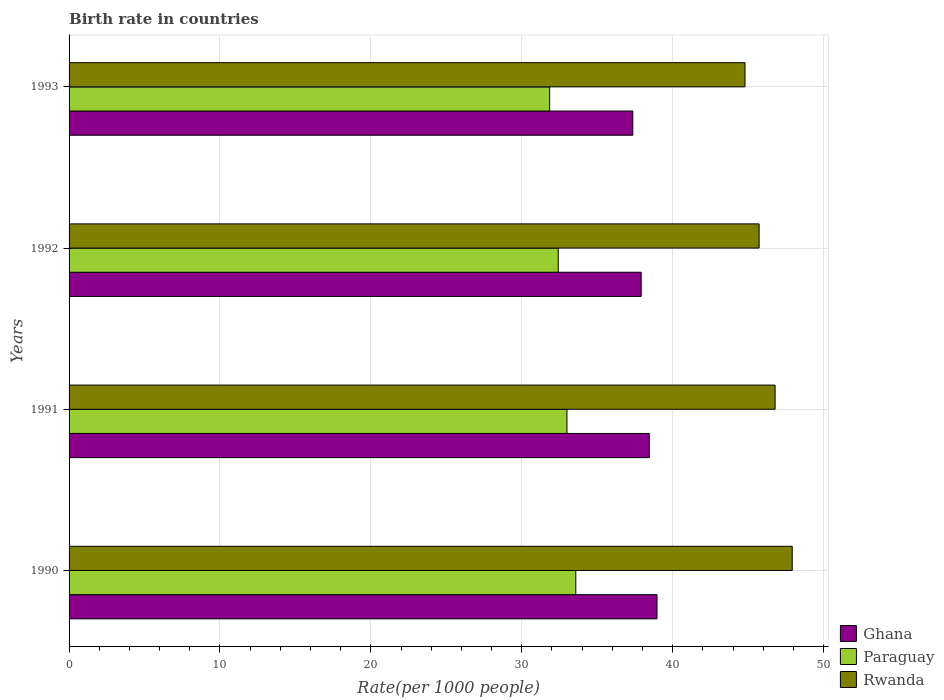Are the number of bars per tick equal to the number of legend labels?
Ensure brevity in your answer.  Yes. Are the number of bars on each tick of the Y-axis equal?
Offer a terse response. Yes. How many bars are there on the 4th tick from the bottom?
Provide a short and direct response. 3. What is the birth rate in Rwanda in 1992?
Offer a very short reply. 45.73. Across all years, what is the maximum birth rate in Paraguay?
Provide a succinct answer. 33.58. Across all years, what is the minimum birth rate in Ghana?
Your response must be concise. 37.36. In which year was the birth rate in Paraguay maximum?
Offer a terse response. 1990. What is the total birth rate in Paraguay in the graph?
Your answer should be compact. 130.83. What is the difference between the birth rate in Ghana in 1990 and that in 1991?
Make the answer very short. 0.51. What is the difference between the birth rate in Paraguay in 1992 and the birth rate in Ghana in 1993?
Make the answer very short. -4.94. What is the average birth rate in Ghana per year?
Offer a terse response. 38.17. In the year 1991, what is the difference between the birth rate in Rwanda and birth rate in Ghana?
Your answer should be compact. 8.34. What is the ratio of the birth rate in Paraguay in 1991 to that in 1992?
Provide a succinct answer. 1.02. Is the birth rate in Paraguay in 1990 less than that in 1992?
Give a very brief answer. No. What is the difference between the highest and the second highest birth rate in Ghana?
Offer a very short reply. 0.51. What is the difference between the highest and the lowest birth rate in Rwanda?
Make the answer very short. 3.13. In how many years, is the birth rate in Ghana greater than the average birth rate in Ghana taken over all years?
Ensure brevity in your answer.  2. Is the sum of the birth rate in Rwanda in 1990 and 1991 greater than the maximum birth rate in Ghana across all years?
Your answer should be very brief. Yes. What does the 2nd bar from the top in 1992 represents?
Offer a very short reply. Paraguay. What does the 2nd bar from the bottom in 1993 represents?
Keep it short and to the point. Paraguay. Is it the case that in every year, the sum of the birth rate in Paraguay and birth rate in Rwanda is greater than the birth rate in Ghana?
Provide a short and direct response. Yes. How many bars are there?
Make the answer very short. 12. Are all the bars in the graph horizontal?
Offer a terse response. Yes. Are the values on the major ticks of X-axis written in scientific E-notation?
Ensure brevity in your answer.  No. Does the graph contain any zero values?
Your response must be concise. No. Where does the legend appear in the graph?
Provide a succinct answer. Bottom right. What is the title of the graph?
Offer a very short reply. Birth rate in countries. What is the label or title of the X-axis?
Provide a short and direct response. Rate(per 1000 people). What is the label or title of the Y-axis?
Keep it short and to the point. Years. What is the Rate(per 1000 people) of Ghana in 1990?
Give a very brief answer. 38.96. What is the Rate(per 1000 people) of Paraguay in 1990?
Your answer should be very brief. 33.58. What is the Rate(per 1000 people) in Rwanda in 1990?
Provide a succinct answer. 47.92. What is the Rate(per 1000 people) in Ghana in 1991?
Offer a very short reply. 38.45. What is the Rate(per 1000 people) of Paraguay in 1991?
Your answer should be compact. 32.99. What is the Rate(per 1000 people) of Rwanda in 1991?
Your answer should be very brief. 46.79. What is the Rate(per 1000 people) of Ghana in 1992?
Your answer should be very brief. 37.91. What is the Rate(per 1000 people) in Paraguay in 1992?
Offer a terse response. 32.41. What is the Rate(per 1000 people) of Rwanda in 1992?
Offer a terse response. 45.73. What is the Rate(per 1000 people) in Ghana in 1993?
Provide a short and direct response. 37.36. What is the Rate(per 1000 people) of Paraguay in 1993?
Your answer should be compact. 31.85. What is the Rate(per 1000 people) in Rwanda in 1993?
Give a very brief answer. 44.79. Across all years, what is the maximum Rate(per 1000 people) in Ghana?
Keep it short and to the point. 38.96. Across all years, what is the maximum Rate(per 1000 people) in Paraguay?
Provide a succinct answer. 33.58. Across all years, what is the maximum Rate(per 1000 people) of Rwanda?
Offer a very short reply. 47.92. Across all years, what is the minimum Rate(per 1000 people) in Ghana?
Keep it short and to the point. 37.36. Across all years, what is the minimum Rate(per 1000 people) in Paraguay?
Ensure brevity in your answer.  31.85. Across all years, what is the minimum Rate(per 1000 people) of Rwanda?
Offer a terse response. 44.79. What is the total Rate(per 1000 people) in Ghana in the graph?
Offer a terse response. 152.68. What is the total Rate(per 1000 people) of Paraguay in the graph?
Provide a succinct answer. 130.83. What is the total Rate(per 1000 people) in Rwanda in the graph?
Give a very brief answer. 185.23. What is the difference between the Rate(per 1000 people) of Ghana in 1990 and that in 1991?
Keep it short and to the point. 0.51. What is the difference between the Rate(per 1000 people) in Paraguay in 1990 and that in 1991?
Offer a terse response. 0.59. What is the difference between the Rate(per 1000 people) of Rwanda in 1990 and that in 1991?
Offer a very short reply. 1.14. What is the difference between the Rate(per 1000 people) in Ghana in 1990 and that in 1992?
Ensure brevity in your answer.  1.05. What is the difference between the Rate(per 1000 people) of Paraguay in 1990 and that in 1992?
Keep it short and to the point. 1.16. What is the difference between the Rate(per 1000 people) of Rwanda in 1990 and that in 1992?
Your response must be concise. 2.19. What is the difference between the Rate(per 1000 people) of Ghana in 1990 and that in 1993?
Your answer should be very brief. 1.6. What is the difference between the Rate(per 1000 people) of Paraguay in 1990 and that in 1993?
Make the answer very short. 1.73. What is the difference between the Rate(per 1000 people) in Rwanda in 1990 and that in 1993?
Your response must be concise. 3.13. What is the difference between the Rate(per 1000 people) of Ghana in 1991 and that in 1992?
Your answer should be very brief. 0.54. What is the difference between the Rate(per 1000 people) of Paraguay in 1991 and that in 1992?
Your response must be concise. 0.58. What is the difference between the Rate(per 1000 people) of Rwanda in 1991 and that in 1992?
Provide a short and direct response. 1.06. What is the difference between the Rate(per 1000 people) of Ghana in 1991 and that in 1993?
Provide a succinct answer. 1.09. What is the difference between the Rate(per 1000 people) in Paraguay in 1991 and that in 1993?
Offer a very short reply. 1.15. What is the difference between the Rate(per 1000 people) of Rwanda in 1991 and that in 1993?
Offer a very short reply. 2. What is the difference between the Rate(per 1000 people) of Ghana in 1992 and that in 1993?
Provide a succinct answer. 0.56. What is the difference between the Rate(per 1000 people) of Paraguay in 1992 and that in 1993?
Offer a very short reply. 0.57. What is the difference between the Rate(per 1000 people) of Rwanda in 1992 and that in 1993?
Make the answer very short. 0.94. What is the difference between the Rate(per 1000 people) in Ghana in 1990 and the Rate(per 1000 people) in Paraguay in 1991?
Your answer should be very brief. 5.97. What is the difference between the Rate(per 1000 people) in Ghana in 1990 and the Rate(per 1000 people) in Rwanda in 1991?
Provide a short and direct response. -7.83. What is the difference between the Rate(per 1000 people) in Paraguay in 1990 and the Rate(per 1000 people) in Rwanda in 1991?
Your response must be concise. -13.21. What is the difference between the Rate(per 1000 people) in Ghana in 1990 and the Rate(per 1000 people) in Paraguay in 1992?
Offer a terse response. 6.55. What is the difference between the Rate(per 1000 people) in Ghana in 1990 and the Rate(per 1000 people) in Rwanda in 1992?
Your answer should be very brief. -6.77. What is the difference between the Rate(per 1000 people) in Paraguay in 1990 and the Rate(per 1000 people) in Rwanda in 1992?
Provide a short and direct response. -12.15. What is the difference between the Rate(per 1000 people) of Ghana in 1990 and the Rate(per 1000 people) of Paraguay in 1993?
Your answer should be compact. 7.11. What is the difference between the Rate(per 1000 people) in Ghana in 1990 and the Rate(per 1000 people) in Rwanda in 1993?
Offer a very short reply. -5.83. What is the difference between the Rate(per 1000 people) of Paraguay in 1990 and the Rate(per 1000 people) of Rwanda in 1993?
Make the answer very short. -11.21. What is the difference between the Rate(per 1000 people) of Ghana in 1991 and the Rate(per 1000 people) of Paraguay in 1992?
Offer a very short reply. 6.03. What is the difference between the Rate(per 1000 people) of Ghana in 1991 and the Rate(per 1000 people) of Rwanda in 1992?
Your answer should be compact. -7.28. What is the difference between the Rate(per 1000 people) in Paraguay in 1991 and the Rate(per 1000 people) in Rwanda in 1992?
Offer a terse response. -12.73. What is the difference between the Rate(per 1000 people) in Ghana in 1991 and the Rate(per 1000 people) in Paraguay in 1993?
Provide a short and direct response. 6.6. What is the difference between the Rate(per 1000 people) in Ghana in 1991 and the Rate(per 1000 people) in Rwanda in 1993?
Provide a short and direct response. -6.34. What is the difference between the Rate(per 1000 people) in Paraguay in 1991 and the Rate(per 1000 people) in Rwanda in 1993?
Offer a very short reply. -11.8. What is the difference between the Rate(per 1000 people) in Ghana in 1992 and the Rate(per 1000 people) in Paraguay in 1993?
Your answer should be compact. 6.06. What is the difference between the Rate(per 1000 people) in Ghana in 1992 and the Rate(per 1000 people) in Rwanda in 1993?
Keep it short and to the point. -6.88. What is the difference between the Rate(per 1000 people) of Paraguay in 1992 and the Rate(per 1000 people) of Rwanda in 1993?
Offer a terse response. -12.38. What is the average Rate(per 1000 people) in Ghana per year?
Make the answer very short. 38.17. What is the average Rate(per 1000 people) of Paraguay per year?
Your answer should be very brief. 32.71. What is the average Rate(per 1000 people) of Rwanda per year?
Ensure brevity in your answer.  46.31. In the year 1990, what is the difference between the Rate(per 1000 people) in Ghana and Rate(per 1000 people) in Paraguay?
Make the answer very short. 5.38. In the year 1990, what is the difference between the Rate(per 1000 people) of Ghana and Rate(per 1000 people) of Rwanda?
Give a very brief answer. -8.96. In the year 1990, what is the difference between the Rate(per 1000 people) of Paraguay and Rate(per 1000 people) of Rwanda?
Make the answer very short. -14.34. In the year 1991, what is the difference between the Rate(per 1000 people) of Ghana and Rate(per 1000 people) of Paraguay?
Your answer should be compact. 5.46. In the year 1991, what is the difference between the Rate(per 1000 people) of Ghana and Rate(per 1000 people) of Rwanda?
Offer a very short reply. -8.34. In the year 1991, what is the difference between the Rate(per 1000 people) in Paraguay and Rate(per 1000 people) in Rwanda?
Your answer should be compact. -13.79. In the year 1992, what is the difference between the Rate(per 1000 people) of Ghana and Rate(per 1000 people) of Paraguay?
Your answer should be compact. 5.5. In the year 1992, what is the difference between the Rate(per 1000 people) of Ghana and Rate(per 1000 people) of Rwanda?
Provide a succinct answer. -7.82. In the year 1992, what is the difference between the Rate(per 1000 people) in Paraguay and Rate(per 1000 people) in Rwanda?
Ensure brevity in your answer.  -13.31. In the year 1993, what is the difference between the Rate(per 1000 people) of Ghana and Rate(per 1000 people) of Paraguay?
Provide a succinct answer. 5.51. In the year 1993, what is the difference between the Rate(per 1000 people) of Ghana and Rate(per 1000 people) of Rwanda?
Offer a terse response. -7.44. In the year 1993, what is the difference between the Rate(per 1000 people) of Paraguay and Rate(per 1000 people) of Rwanda?
Provide a short and direct response. -12.95. What is the ratio of the Rate(per 1000 people) of Ghana in 1990 to that in 1991?
Offer a terse response. 1.01. What is the ratio of the Rate(per 1000 people) of Paraguay in 1990 to that in 1991?
Provide a succinct answer. 1.02. What is the ratio of the Rate(per 1000 people) in Rwanda in 1990 to that in 1991?
Your response must be concise. 1.02. What is the ratio of the Rate(per 1000 people) in Ghana in 1990 to that in 1992?
Provide a short and direct response. 1.03. What is the ratio of the Rate(per 1000 people) of Paraguay in 1990 to that in 1992?
Your answer should be compact. 1.04. What is the ratio of the Rate(per 1000 people) in Rwanda in 1990 to that in 1992?
Your response must be concise. 1.05. What is the ratio of the Rate(per 1000 people) of Ghana in 1990 to that in 1993?
Ensure brevity in your answer.  1.04. What is the ratio of the Rate(per 1000 people) in Paraguay in 1990 to that in 1993?
Ensure brevity in your answer.  1.05. What is the ratio of the Rate(per 1000 people) in Rwanda in 1990 to that in 1993?
Offer a terse response. 1.07. What is the ratio of the Rate(per 1000 people) in Ghana in 1991 to that in 1992?
Keep it short and to the point. 1.01. What is the ratio of the Rate(per 1000 people) in Paraguay in 1991 to that in 1992?
Ensure brevity in your answer.  1.02. What is the ratio of the Rate(per 1000 people) in Rwanda in 1991 to that in 1992?
Your response must be concise. 1.02. What is the ratio of the Rate(per 1000 people) in Ghana in 1991 to that in 1993?
Offer a terse response. 1.03. What is the ratio of the Rate(per 1000 people) in Paraguay in 1991 to that in 1993?
Give a very brief answer. 1.04. What is the ratio of the Rate(per 1000 people) of Rwanda in 1991 to that in 1993?
Make the answer very short. 1.04. What is the ratio of the Rate(per 1000 people) of Ghana in 1992 to that in 1993?
Provide a short and direct response. 1.01. What is the ratio of the Rate(per 1000 people) in Paraguay in 1992 to that in 1993?
Ensure brevity in your answer.  1.02. What is the ratio of the Rate(per 1000 people) of Rwanda in 1992 to that in 1993?
Your response must be concise. 1.02. What is the difference between the highest and the second highest Rate(per 1000 people) in Ghana?
Your response must be concise. 0.51. What is the difference between the highest and the second highest Rate(per 1000 people) of Paraguay?
Ensure brevity in your answer.  0.59. What is the difference between the highest and the second highest Rate(per 1000 people) in Rwanda?
Ensure brevity in your answer.  1.14. What is the difference between the highest and the lowest Rate(per 1000 people) in Ghana?
Make the answer very short. 1.6. What is the difference between the highest and the lowest Rate(per 1000 people) in Paraguay?
Offer a very short reply. 1.73. What is the difference between the highest and the lowest Rate(per 1000 people) in Rwanda?
Provide a succinct answer. 3.13. 